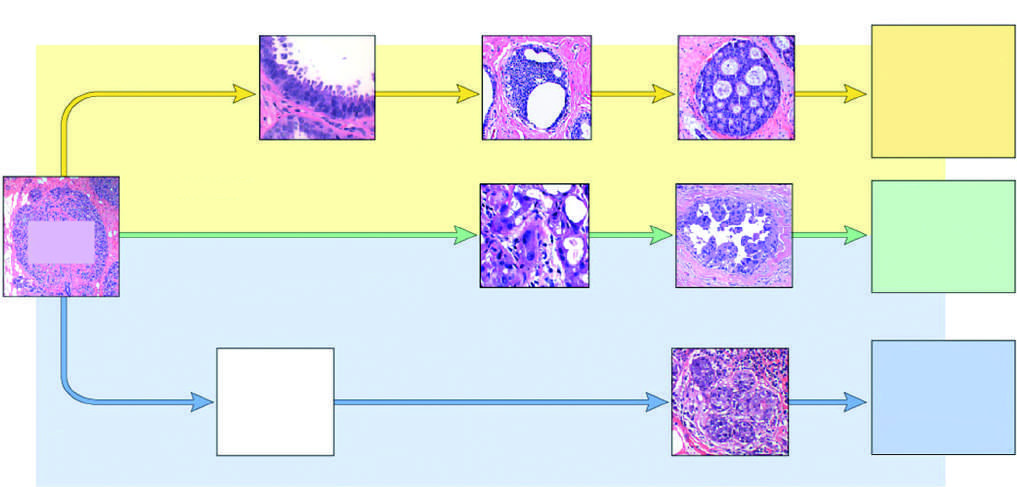re these cancers classified as luminal by gene expression profiling?
Answer the question using a single word or phrase. Yes 